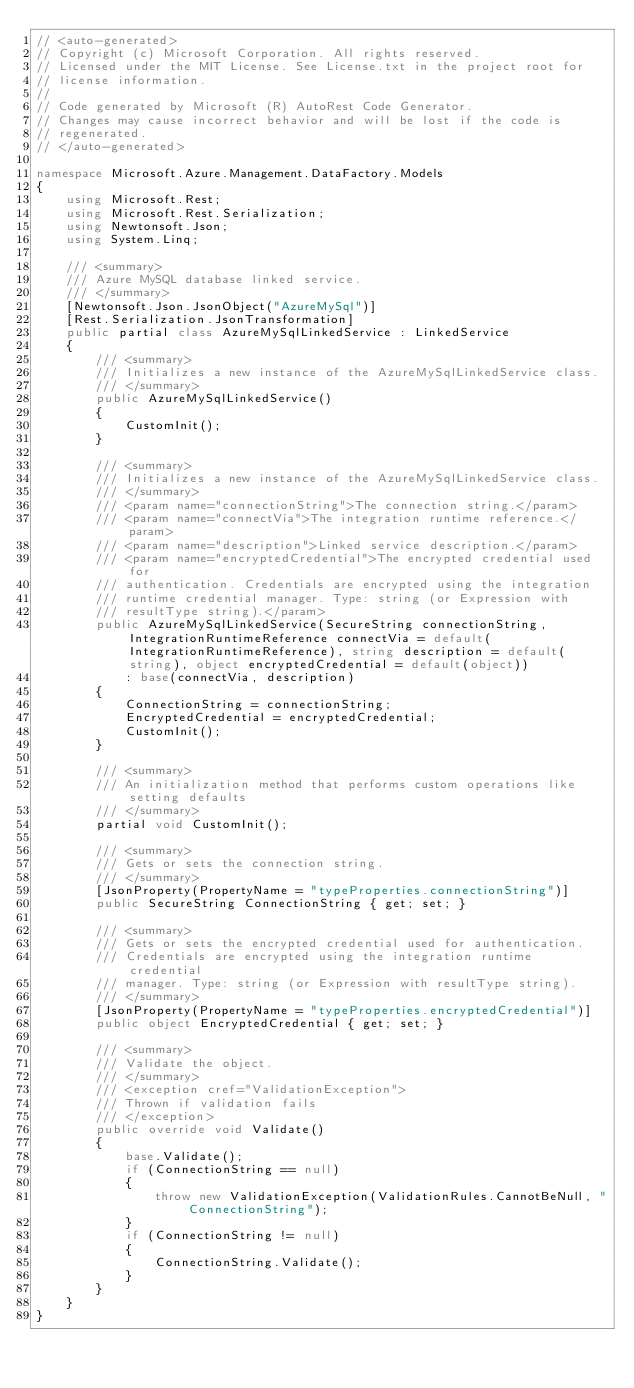<code> <loc_0><loc_0><loc_500><loc_500><_C#_>// <auto-generated>
// Copyright (c) Microsoft Corporation. All rights reserved.
// Licensed under the MIT License. See License.txt in the project root for
// license information.
//
// Code generated by Microsoft (R) AutoRest Code Generator.
// Changes may cause incorrect behavior and will be lost if the code is
// regenerated.
// </auto-generated>

namespace Microsoft.Azure.Management.DataFactory.Models
{
    using Microsoft.Rest;
    using Microsoft.Rest.Serialization;
    using Newtonsoft.Json;
    using System.Linq;

    /// <summary>
    /// Azure MySQL database linked service.
    /// </summary>
    [Newtonsoft.Json.JsonObject("AzureMySql")]
    [Rest.Serialization.JsonTransformation]
    public partial class AzureMySqlLinkedService : LinkedService
    {
        /// <summary>
        /// Initializes a new instance of the AzureMySqlLinkedService class.
        /// </summary>
        public AzureMySqlLinkedService()
        {
            CustomInit();
        }

        /// <summary>
        /// Initializes a new instance of the AzureMySqlLinkedService class.
        /// </summary>
        /// <param name="connectionString">The connection string.</param>
        /// <param name="connectVia">The integration runtime reference.</param>
        /// <param name="description">Linked service description.</param>
        /// <param name="encryptedCredential">The encrypted credential used for
        /// authentication. Credentials are encrypted using the integration
        /// runtime credential manager. Type: string (or Expression with
        /// resultType string).</param>
        public AzureMySqlLinkedService(SecureString connectionString, IntegrationRuntimeReference connectVia = default(IntegrationRuntimeReference), string description = default(string), object encryptedCredential = default(object))
            : base(connectVia, description)
        {
            ConnectionString = connectionString;
            EncryptedCredential = encryptedCredential;
            CustomInit();
        }

        /// <summary>
        /// An initialization method that performs custom operations like setting defaults
        /// </summary>
        partial void CustomInit();

        /// <summary>
        /// Gets or sets the connection string.
        /// </summary>
        [JsonProperty(PropertyName = "typeProperties.connectionString")]
        public SecureString ConnectionString { get; set; }

        /// <summary>
        /// Gets or sets the encrypted credential used for authentication.
        /// Credentials are encrypted using the integration runtime credential
        /// manager. Type: string (or Expression with resultType string).
        /// </summary>
        [JsonProperty(PropertyName = "typeProperties.encryptedCredential")]
        public object EncryptedCredential { get; set; }

        /// <summary>
        /// Validate the object.
        /// </summary>
        /// <exception cref="ValidationException">
        /// Thrown if validation fails
        /// </exception>
        public override void Validate()
        {
            base.Validate();
            if (ConnectionString == null)
            {
                throw new ValidationException(ValidationRules.CannotBeNull, "ConnectionString");
            }
            if (ConnectionString != null)
            {
                ConnectionString.Validate();
            }
        }
    }
}
</code> 